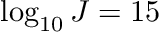Convert formula to latex. <formula><loc_0><loc_0><loc_500><loc_500>\log _ { 1 0 } J = 1 5</formula> 